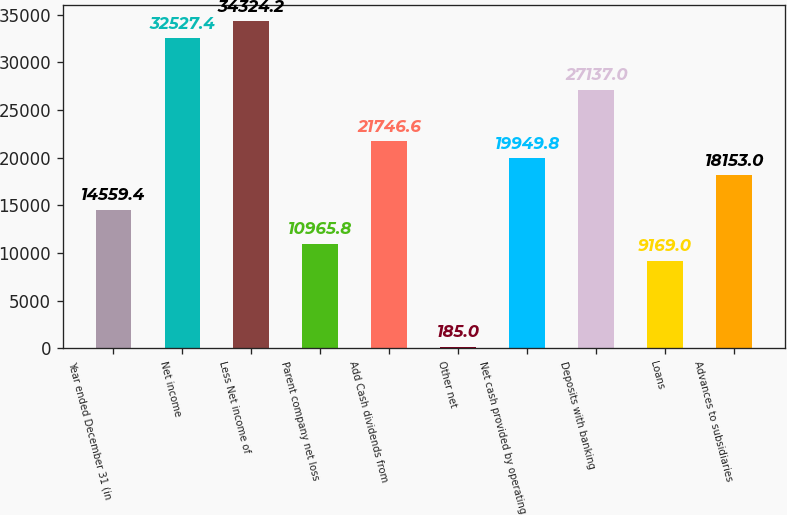<chart> <loc_0><loc_0><loc_500><loc_500><bar_chart><fcel>Year ended December 31 (in<fcel>Net income<fcel>Less Net income of<fcel>Parent company net loss<fcel>Add Cash dividends from<fcel>Other net<fcel>Net cash provided by operating<fcel>Deposits with banking<fcel>Loans<fcel>Advances to subsidiaries<nl><fcel>14559.4<fcel>32527.4<fcel>34324.2<fcel>10965.8<fcel>21746.6<fcel>185<fcel>19949.8<fcel>27137<fcel>9169<fcel>18153<nl></chart> 